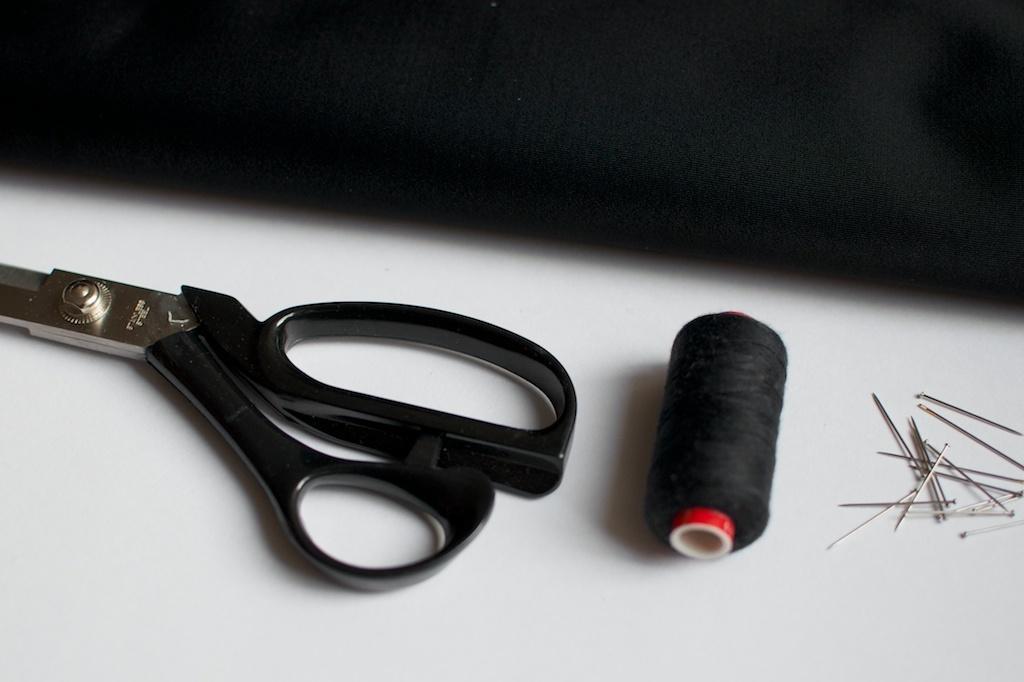Describe this image in one or two sentences. There is a white surface. On that there is a scissors, thread and needles. 